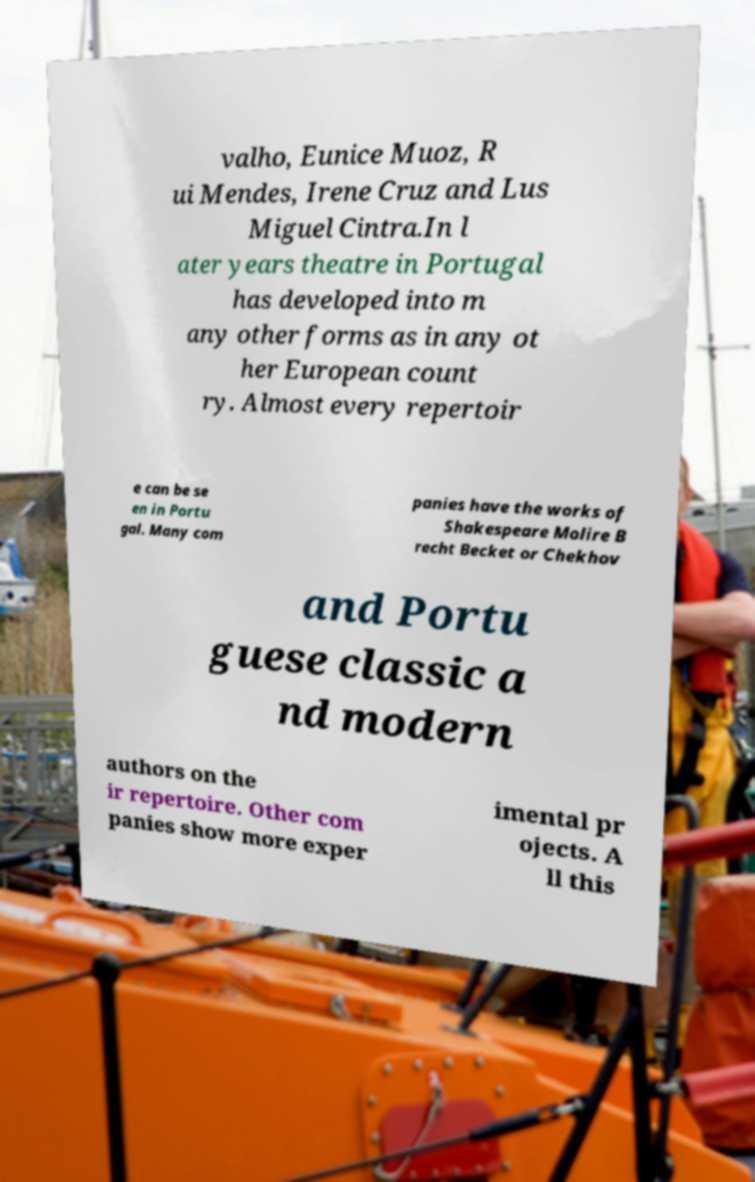Could you assist in decoding the text presented in this image and type it out clearly? valho, Eunice Muoz, R ui Mendes, Irene Cruz and Lus Miguel Cintra.In l ater years theatre in Portugal has developed into m any other forms as in any ot her European count ry. Almost every repertoir e can be se en in Portu gal. Many com panies have the works of Shakespeare Molire B recht Becket or Chekhov and Portu guese classic a nd modern authors on the ir repertoire. Other com panies show more exper imental pr ojects. A ll this 